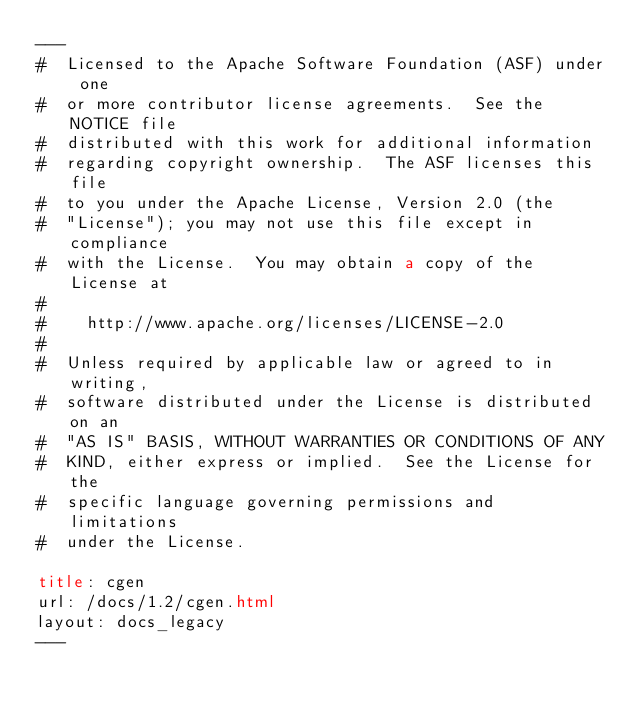<code> <loc_0><loc_0><loc_500><loc_500><_HTML_>---
#  Licensed to the Apache Software Foundation (ASF) under one
#  or more contributor license agreements.  See the NOTICE file
#  distributed with this work for additional information
#  regarding copyright ownership.  The ASF licenses this file
#  to you under the Apache License, Version 2.0 (the
#  "License"); you may not use this file except in compliance
#  with the License.  You may obtain a copy of the License at
#
#    http://www.apache.org/licenses/LICENSE-2.0
#
#  Unless required by applicable law or agreed to in writing,
#  software distributed under the License is distributed on an
#  "AS IS" BASIS, WITHOUT WARRANTIES OR CONDITIONS OF ANY
#  KIND, either express or implied.  See the License for the
#  specific language governing permissions and limitations
#  under the License.

title: cgen
url: /docs/1.2/cgen.html
layout: docs_legacy
---

	
</code> 